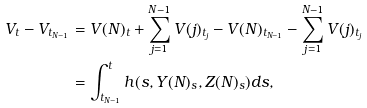<formula> <loc_0><loc_0><loc_500><loc_500>V _ { t } - V _ { t _ { N - 1 } } & = V ( N ) _ { t } + \sum _ { j = 1 } ^ { N - 1 } V ( j ) _ { t _ { j } } - V ( N ) _ { t _ { N - 1 } } - \sum _ { j = 1 } ^ { N - 1 } V ( j ) _ { t _ { j } } \\ & = \int _ { t _ { N - 1 } } ^ { t } h ( s , Y ( N ) _ { s } , Z ( N ) _ { s } ) d s ,</formula> 